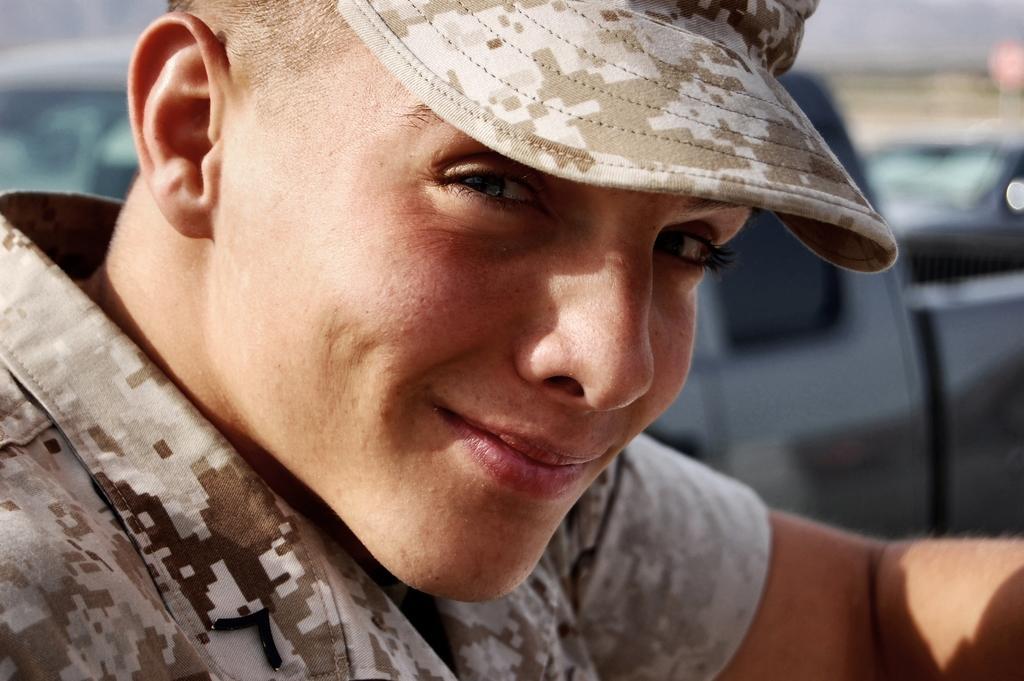Describe this image in one or two sentences. As we can see in the image there is a man wearing a hat and the background is blurred. 